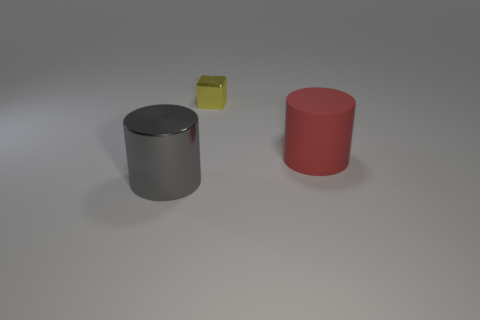Add 2 shiny cylinders. How many objects exist? 5 Subtract all cylinders. How many objects are left? 1 Subtract all cyan cylinders. How many purple cubes are left? 0 Add 2 cylinders. How many cylinders are left? 4 Add 1 large red matte objects. How many large red matte objects exist? 2 Subtract 0 cyan cubes. How many objects are left? 3 Subtract 1 cubes. How many cubes are left? 0 Subtract all blue cylinders. Subtract all yellow cubes. How many cylinders are left? 2 Subtract all big green shiny objects. Subtract all small metal things. How many objects are left? 2 